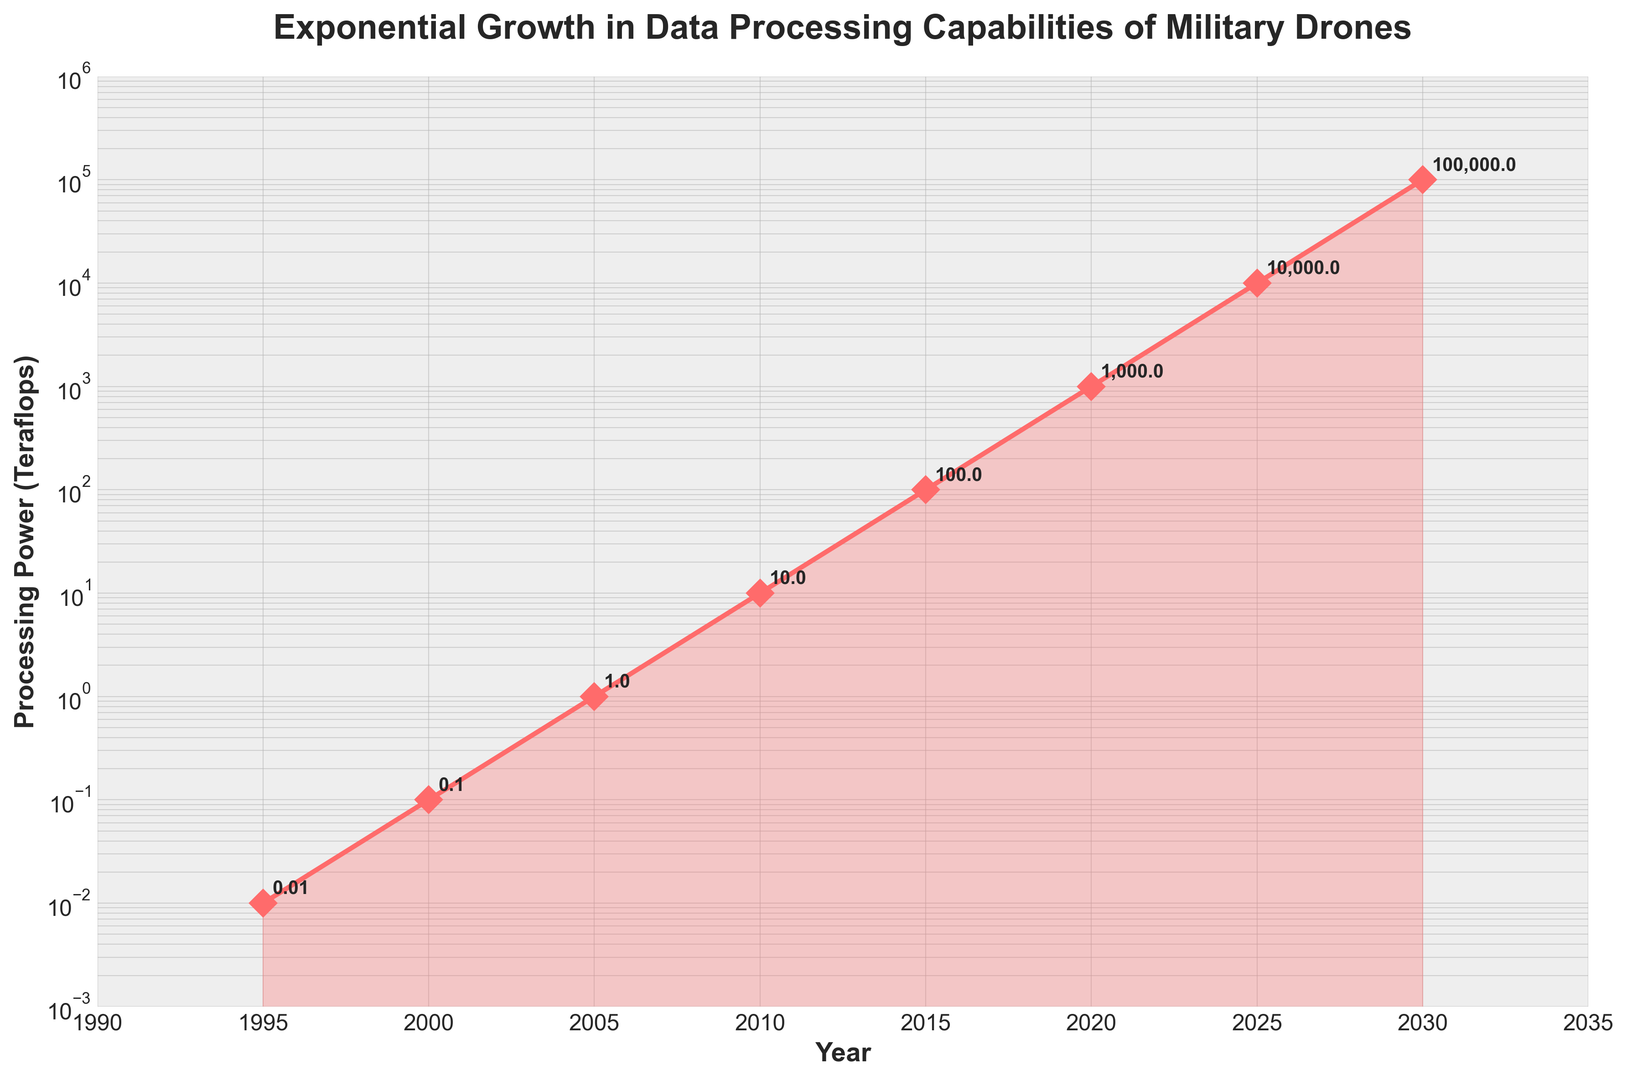What is the processing power of military drones in 2005? According to the figure, we need to find the teraflops value corresponding to the year 2005. The chart shows 1 teraflop for 2005.
Answer: 1 teraflop How much did the processing power increase from 2000 to 2010? From the figure, the teraflops in 2000 is 0.1 and in 2010 is 10. Subtract the earlier value from the later one (10 - 0.1) to get the increase, which is 9.9 teraflops.
Answer: 9.9 teraflops By how many times did the processing power of drones increase between 1995 and 2020? In 1995, the processing power was 0.01 teraflops, and in 2020, it was 1000 teraflops. To find the factor of increase, divide the later value by the earlier one (1000 / 0.01), which equals 100,000 times.
Answer: 100,000 times Which year shows the highest growth rate in processing power? To identify the year with the highest growth rate, look at the exponential jumps between the years. The largest increase in visual terms is from 2025 to 2030.
Answer: 2025 to 2030 By how much did the processing power increase from 2010 to 2015 compared to 2015 to 2020? The processing power in 2010 is 10 teraflops, in 2015 is 100 teraflops, and in 2020 is 1000 teraflops. Increase from 2010 to 2015 is 100 - 10 = 90 teraflops and from 2015 to 2020 is 1000 - 100 = 900 teraflops.
Answer: 90 teraflops vs. 900 teraflops What is noticeable about the color shade near the data points? The graph uses a pink-ish (red) color to mark the data points and a lighter shade to fill the area under the curve. This highlights the exponential increase visually.
Answer: Exponential increase highlighted visually How many times greater is the processing power in 2030 than in 1995? In 1995, the processing power is 0.01 teraflops and in 2030 is 100,000 teraflops. To find how many times greater, divide 100,000 by 0.01, resulting in 10,000,000 times.
Answer: 10,000,000 times Considering the pattern from 1995 to 2020, predict the teraflops for the year 2035. The processing power increases by a factor of 10 every 5 years. Following this, from 2030 (100,000 teraflops), the next prediction for 2035 would be 1,000,000 teraflops.
Answer: 1,000,000 teraflops 